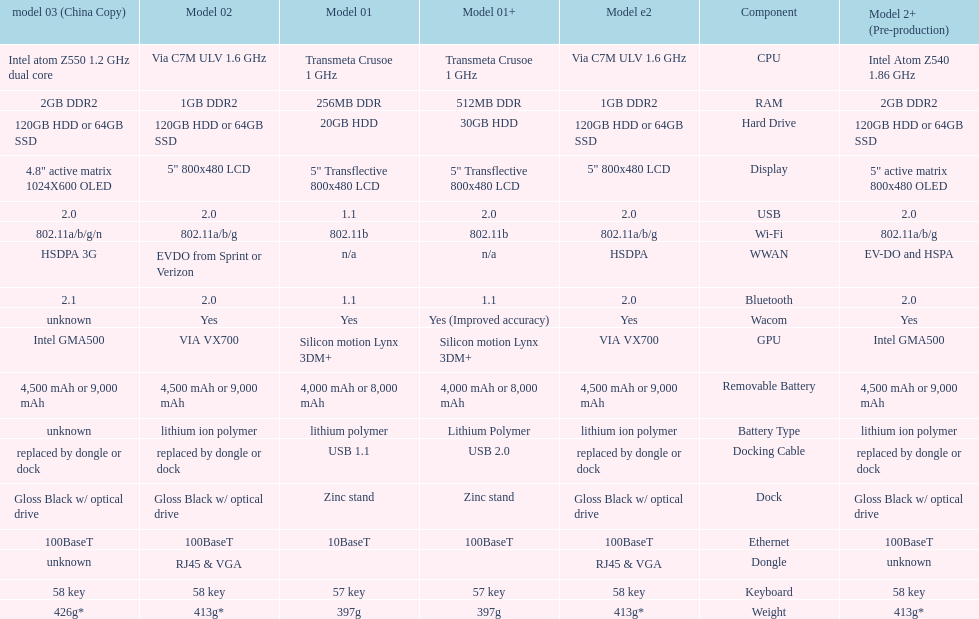The model 2 and the model 2e have what type of cpu? Via C7M ULV 1.6 GHz. 